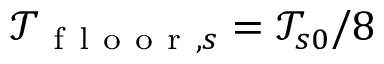<formula> <loc_0><loc_0><loc_500><loc_500>\mathcal { T } _ { f l o o r , s } = \mathcal { T } _ { s 0 } / 8</formula> 